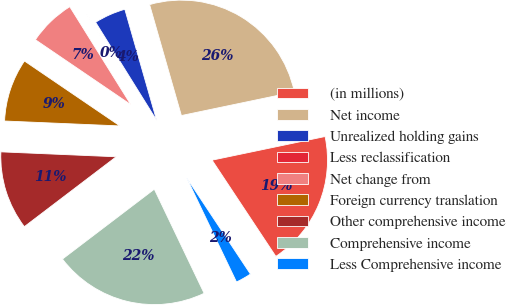Convert chart to OTSL. <chart><loc_0><loc_0><loc_500><loc_500><pie_chart><fcel>(in millions)<fcel>Net income<fcel>Unrealized holding gains<fcel>Less reclassification<fcel>Net change from<fcel>Foreign currency translation<fcel>Other comprehensive income<fcel>Comprehensive income<fcel>Less Comprehensive income<nl><fcel>18.97%<fcel>26.16%<fcel>4.42%<fcel>0.01%<fcel>6.62%<fcel>8.83%<fcel>11.03%<fcel>21.75%<fcel>2.21%<nl></chart> 